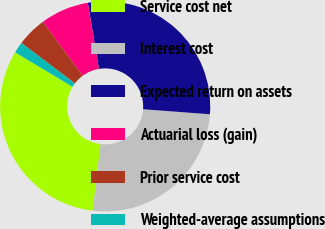<chart> <loc_0><loc_0><loc_500><loc_500><pie_chart><fcel>Service cost net<fcel>Interest cost<fcel>Expected return on assets<fcel>Actuarial loss (gain)<fcel>Prior service cost<fcel>Weighted-average assumptions<nl><fcel>31.72%<fcel>25.69%<fcel>28.84%<fcel>7.46%<fcel>4.58%<fcel>1.71%<nl></chart> 